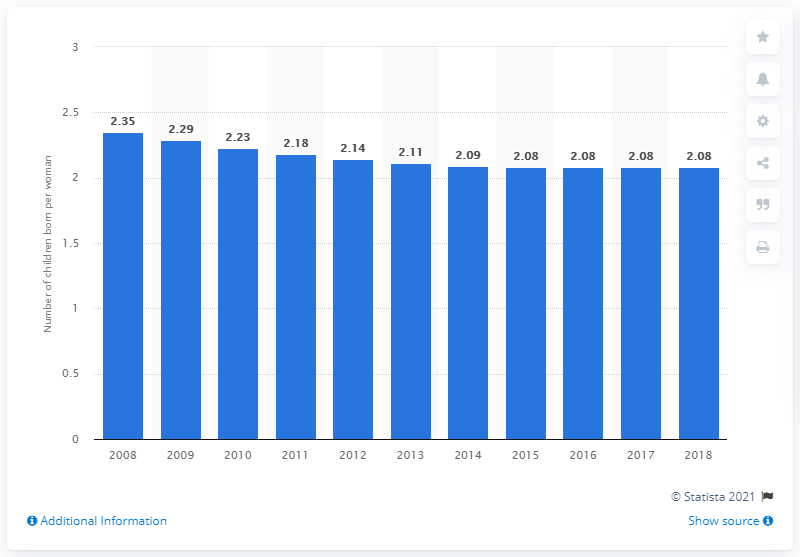Outline some significant characteristics in this image. In 2018, Kuwait's fertility rate was 2.08. 